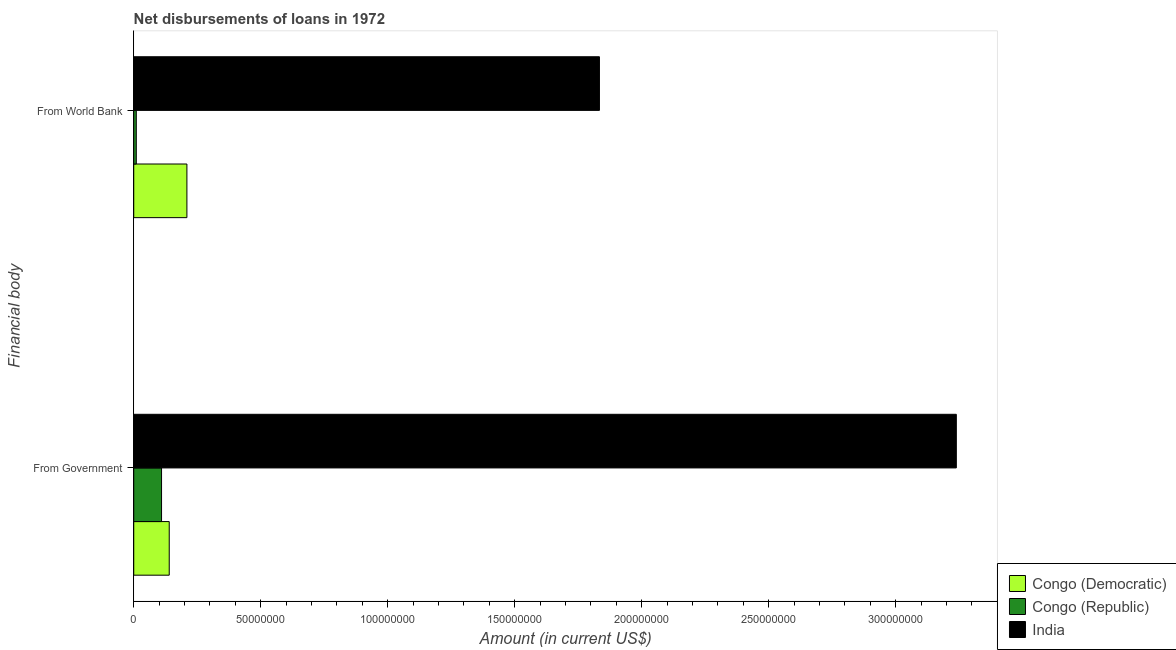How many different coloured bars are there?
Provide a succinct answer. 3. Are the number of bars per tick equal to the number of legend labels?
Your response must be concise. Yes. Are the number of bars on each tick of the Y-axis equal?
Offer a terse response. Yes. How many bars are there on the 1st tick from the bottom?
Ensure brevity in your answer.  3. What is the label of the 1st group of bars from the top?
Give a very brief answer. From World Bank. What is the net disbursements of loan from world bank in Congo (Republic)?
Provide a short and direct response. 1.01e+06. Across all countries, what is the maximum net disbursements of loan from government?
Offer a very short reply. 3.24e+08. Across all countries, what is the minimum net disbursements of loan from world bank?
Make the answer very short. 1.01e+06. In which country was the net disbursements of loan from government minimum?
Keep it short and to the point. Congo (Republic). What is the total net disbursements of loan from world bank in the graph?
Ensure brevity in your answer.  2.05e+08. What is the difference between the net disbursements of loan from government in Congo (Democratic) and that in Congo (Republic)?
Your answer should be compact. 3.03e+06. What is the difference between the net disbursements of loan from world bank in India and the net disbursements of loan from government in Congo (Republic)?
Ensure brevity in your answer.  1.72e+08. What is the average net disbursements of loan from government per country?
Offer a very short reply. 1.16e+08. What is the difference between the net disbursements of loan from government and net disbursements of loan from world bank in Congo (Republic)?
Give a very brief answer. 9.94e+06. What is the ratio of the net disbursements of loan from world bank in Congo (Republic) to that in Congo (Democratic)?
Your response must be concise. 0.05. What does the 2nd bar from the top in From World Bank represents?
Offer a very short reply. Congo (Republic). What does the 3rd bar from the bottom in From Government represents?
Offer a very short reply. India. How many bars are there?
Your response must be concise. 6. How many countries are there in the graph?
Provide a short and direct response. 3. Does the graph contain any zero values?
Make the answer very short. No. Does the graph contain grids?
Offer a very short reply. No. Where does the legend appear in the graph?
Make the answer very short. Bottom right. How many legend labels are there?
Your response must be concise. 3. What is the title of the graph?
Offer a terse response. Net disbursements of loans in 1972. What is the label or title of the X-axis?
Ensure brevity in your answer.  Amount (in current US$). What is the label or title of the Y-axis?
Offer a terse response. Financial body. What is the Amount (in current US$) in Congo (Democratic) in From Government?
Your answer should be very brief. 1.40e+07. What is the Amount (in current US$) of Congo (Republic) in From Government?
Your response must be concise. 1.10e+07. What is the Amount (in current US$) in India in From Government?
Make the answer very short. 3.24e+08. What is the Amount (in current US$) of Congo (Democratic) in From World Bank?
Provide a succinct answer. 2.09e+07. What is the Amount (in current US$) of Congo (Republic) in From World Bank?
Your response must be concise. 1.01e+06. What is the Amount (in current US$) in India in From World Bank?
Provide a succinct answer. 1.83e+08. Across all Financial body, what is the maximum Amount (in current US$) in Congo (Democratic)?
Ensure brevity in your answer.  2.09e+07. Across all Financial body, what is the maximum Amount (in current US$) in Congo (Republic)?
Provide a short and direct response. 1.10e+07. Across all Financial body, what is the maximum Amount (in current US$) in India?
Give a very brief answer. 3.24e+08. Across all Financial body, what is the minimum Amount (in current US$) in Congo (Democratic)?
Provide a succinct answer. 1.40e+07. Across all Financial body, what is the minimum Amount (in current US$) of Congo (Republic)?
Provide a short and direct response. 1.01e+06. Across all Financial body, what is the minimum Amount (in current US$) of India?
Offer a terse response. 1.83e+08. What is the total Amount (in current US$) of Congo (Democratic) in the graph?
Offer a terse response. 3.49e+07. What is the total Amount (in current US$) of Congo (Republic) in the graph?
Offer a terse response. 1.20e+07. What is the total Amount (in current US$) of India in the graph?
Keep it short and to the point. 5.07e+08. What is the difference between the Amount (in current US$) of Congo (Democratic) in From Government and that in From World Bank?
Provide a succinct answer. -6.96e+06. What is the difference between the Amount (in current US$) of Congo (Republic) in From Government and that in From World Bank?
Keep it short and to the point. 9.94e+06. What is the difference between the Amount (in current US$) in India in From Government and that in From World Bank?
Give a very brief answer. 1.41e+08. What is the difference between the Amount (in current US$) in Congo (Democratic) in From Government and the Amount (in current US$) in Congo (Republic) in From World Bank?
Your answer should be very brief. 1.30e+07. What is the difference between the Amount (in current US$) in Congo (Democratic) in From Government and the Amount (in current US$) in India in From World Bank?
Give a very brief answer. -1.69e+08. What is the difference between the Amount (in current US$) in Congo (Republic) in From Government and the Amount (in current US$) in India in From World Bank?
Make the answer very short. -1.72e+08. What is the average Amount (in current US$) in Congo (Democratic) per Financial body?
Ensure brevity in your answer.  1.75e+07. What is the average Amount (in current US$) in Congo (Republic) per Financial body?
Keep it short and to the point. 5.98e+06. What is the average Amount (in current US$) in India per Financial body?
Your answer should be very brief. 2.54e+08. What is the difference between the Amount (in current US$) of Congo (Democratic) and Amount (in current US$) of Congo (Republic) in From Government?
Make the answer very short. 3.03e+06. What is the difference between the Amount (in current US$) in Congo (Democratic) and Amount (in current US$) in India in From Government?
Offer a very short reply. -3.10e+08. What is the difference between the Amount (in current US$) in Congo (Republic) and Amount (in current US$) in India in From Government?
Your answer should be compact. -3.13e+08. What is the difference between the Amount (in current US$) in Congo (Democratic) and Amount (in current US$) in Congo (Republic) in From World Bank?
Offer a terse response. 1.99e+07. What is the difference between the Amount (in current US$) of Congo (Democratic) and Amount (in current US$) of India in From World Bank?
Provide a short and direct response. -1.62e+08. What is the difference between the Amount (in current US$) of Congo (Republic) and Amount (in current US$) of India in From World Bank?
Your answer should be compact. -1.82e+08. What is the ratio of the Amount (in current US$) of Congo (Democratic) in From Government to that in From World Bank?
Offer a terse response. 0.67. What is the ratio of the Amount (in current US$) of Congo (Republic) in From Government to that in From World Bank?
Offer a terse response. 10.85. What is the ratio of the Amount (in current US$) of India in From Government to that in From World Bank?
Offer a terse response. 1.77. What is the difference between the highest and the second highest Amount (in current US$) in Congo (Democratic)?
Give a very brief answer. 6.96e+06. What is the difference between the highest and the second highest Amount (in current US$) of Congo (Republic)?
Ensure brevity in your answer.  9.94e+06. What is the difference between the highest and the second highest Amount (in current US$) in India?
Provide a succinct answer. 1.41e+08. What is the difference between the highest and the lowest Amount (in current US$) of Congo (Democratic)?
Provide a short and direct response. 6.96e+06. What is the difference between the highest and the lowest Amount (in current US$) of Congo (Republic)?
Keep it short and to the point. 9.94e+06. What is the difference between the highest and the lowest Amount (in current US$) of India?
Ensure brevity in your answer.  1.41e+08. 